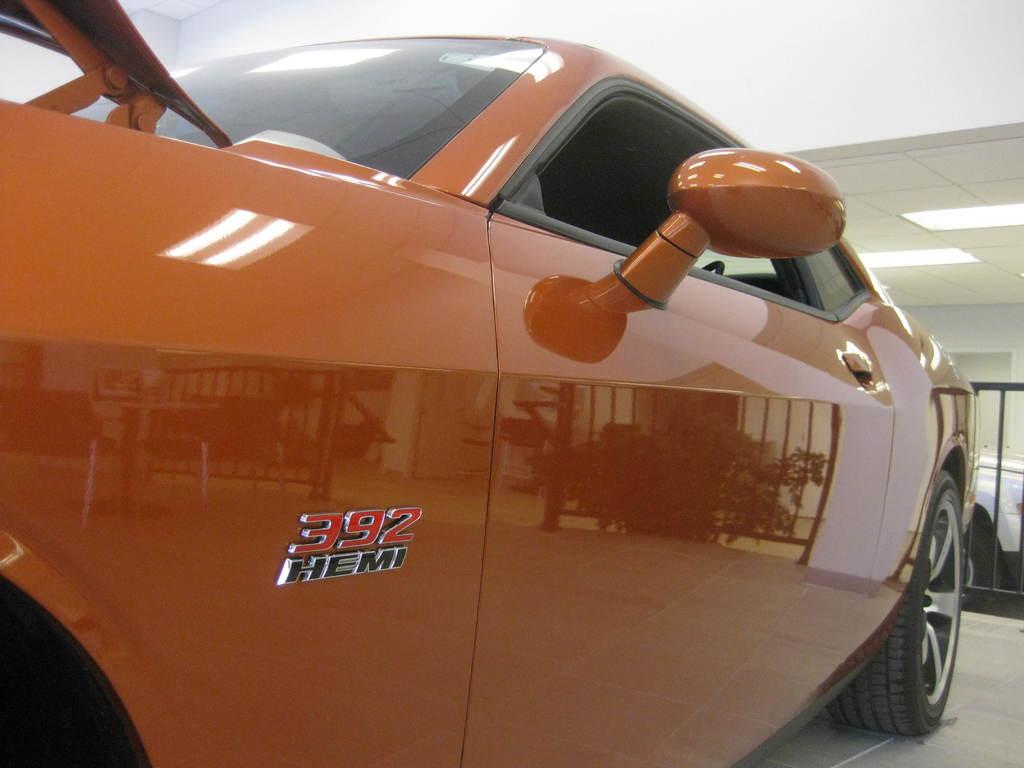What is the main subject of the image? There is a car in the image. Where is the car located? The car is on the ground. What can be seen in the background of the image? There is a roof and lights visible in the background of the image. How many snakes are slithering on the car in the image? There are no snakes present in the image; the car is on the ground with no visible animals. 